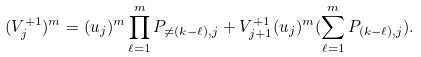Convert formula to latex. <formula><loc_0><loc_0><loc_500><loc_500>( V ^ { + 1 } _ { j } ) ^ { m } = ( u _ { j } ) ^ { m } \prod _ { \ell = 1 } ^ { m } P _ { \neq ( k - \ell ) , j } + V ^ { + 1 } _ { j + 1 } ( u _ { j } ) ^ { m } ( \sum _ { \ell = 1 } ^ { m } P _ { ( k - \ell ) , j } ) .</formula> 